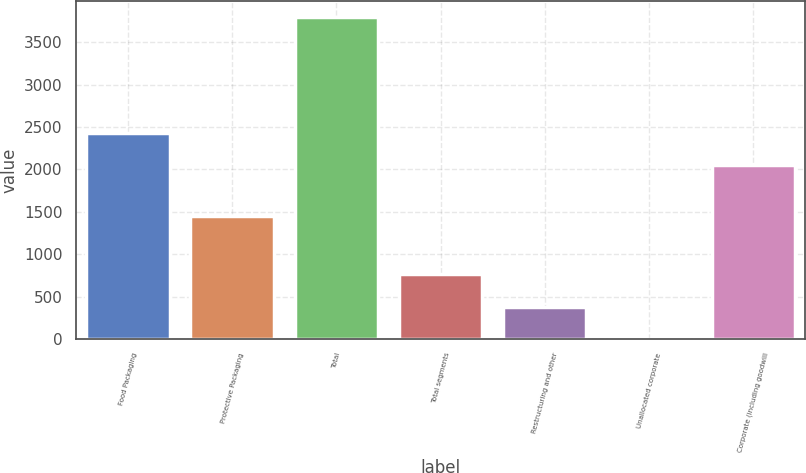<chart> <loc_0><loc_0><loc_500><loc_500><bar_chart><fcel>Food Packaging<fcel>Protective Packaging<fcel>Total<fcel>Total segments<fcel>Restructuring and other<fcel>Unallocated corporate<fcel>Corporate (including goodwill<nl><fcel>2430.42<fcel>1451.2<fcel>3798.1<fcel>760.34<fcel>380.62<fcel>0.9<fcel>2050.7<nl></chart> 